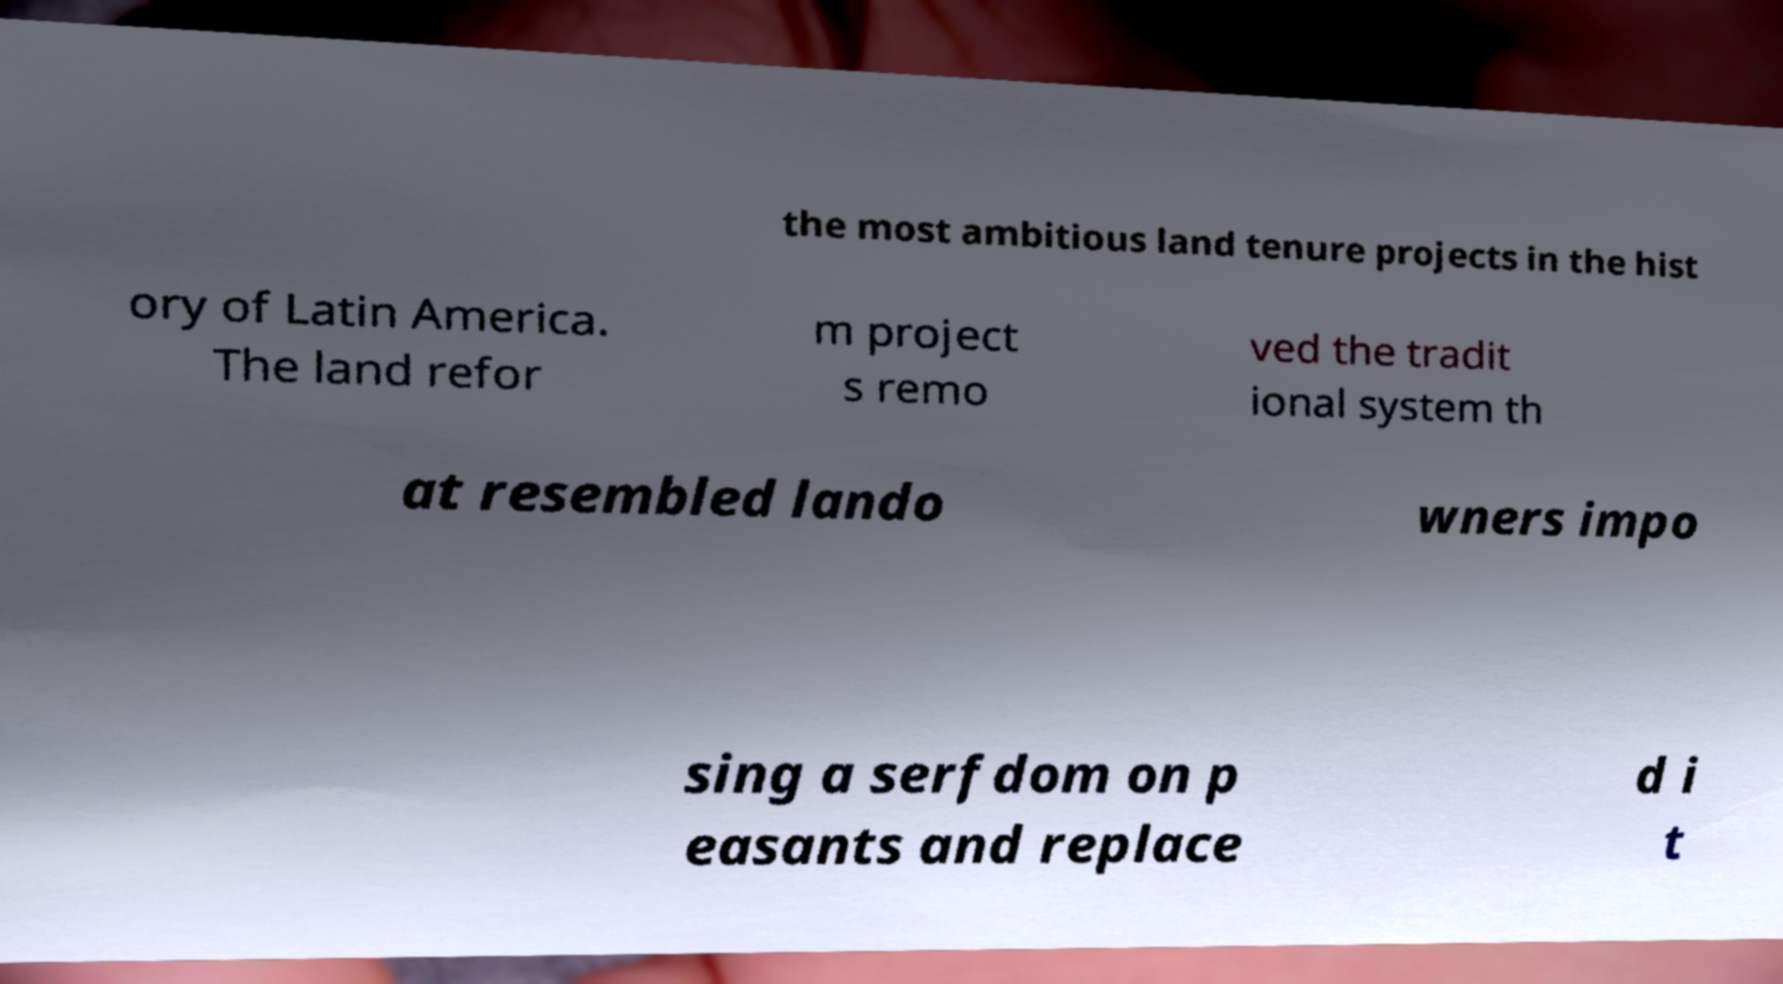What messages or text are displayed in this image? I need them in a readable, typed format. the most ambitious land tenure projects in the hist ory of Latin America. The land refor m project s remo ved the tradit ional system th at resembled lando wners impo sing a serfdom on p easants and replace d i t 